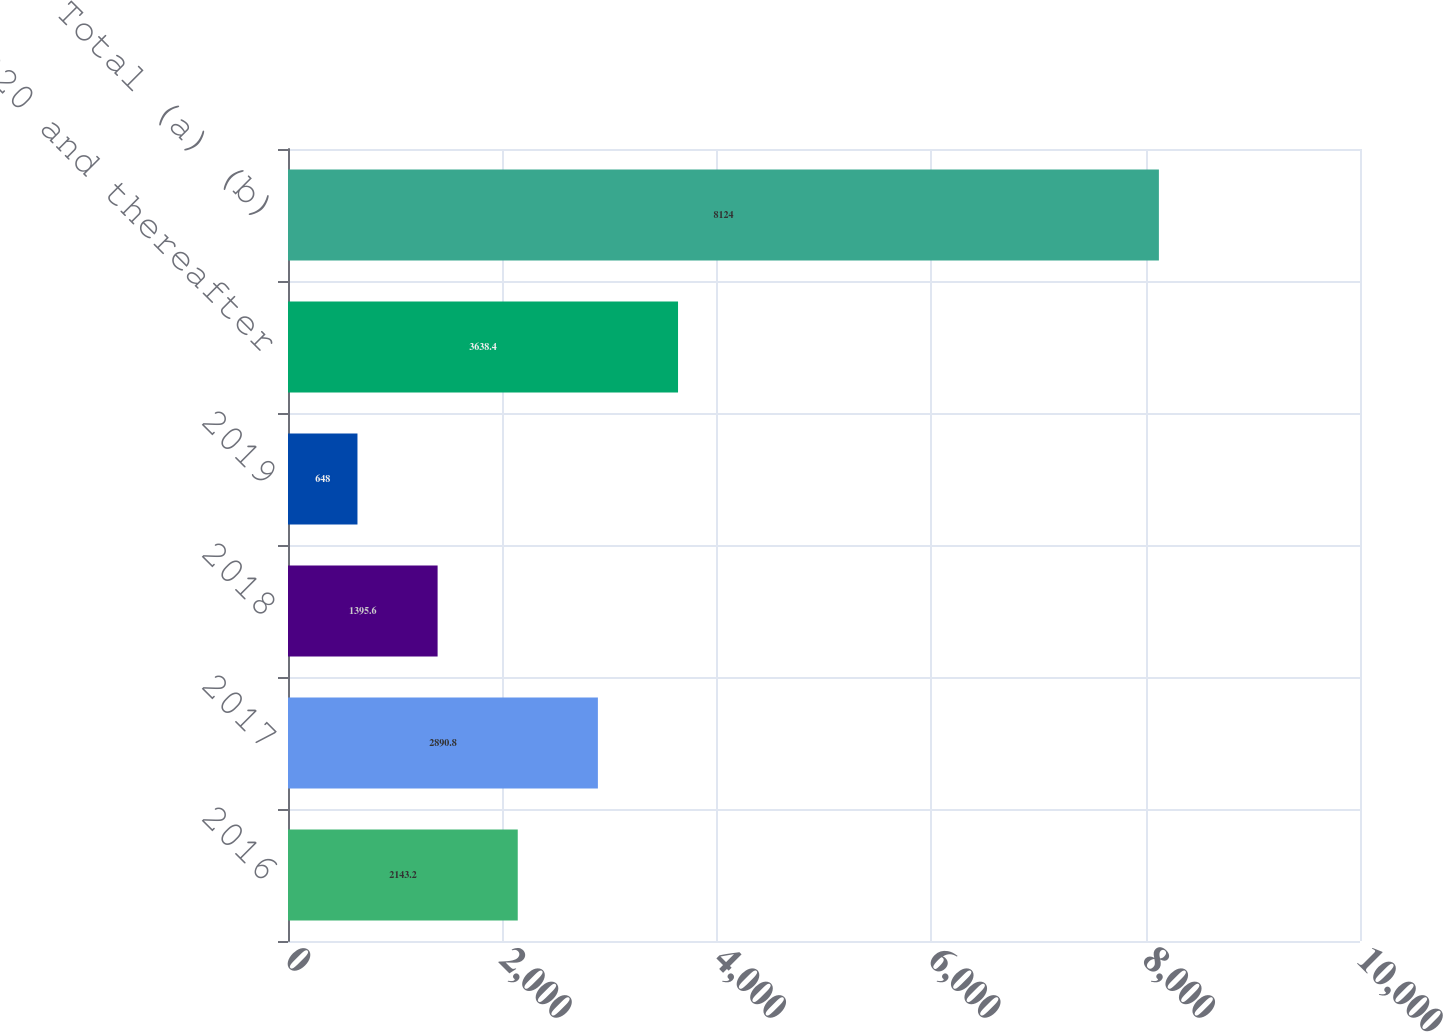Convert chart to OTSL. <chart><loc_0><loc_0><loc_500><loc_500><bar_chart><fcel>2016<fcel>2017<fcel>2018<fcel>2019<fcel>2020 and thereafter<fcel>Total (a) (b)<nl><fcel>2143.2<fcel>2890.8<fcel>1395.6<fcel>648<fcel>3638.4<fcel>8124<nl></chart> 